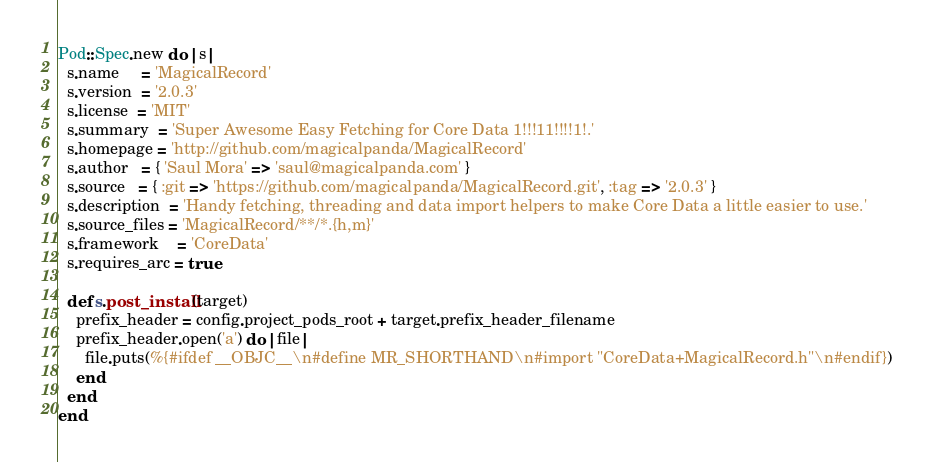Convert code to text. <code><loc_0><loc_0><loc_500><loc_500><_Ruby_>Pod::Spec.new do |s|
  s.name     = 'MagicalRecord'
  s.version  = '2.0.3'
  s.license  = 'MIT'
  s.summary  = 'Super Awesome Easy Fetching for Core Data 1!!!11!!!!1!.'
  s.homepage = 'http://github.com/magicalpanda/MagicalRecord'
  s.author   = { 'Saul Mora' => 'saul@magicalpanda.com' }
  s.source   = { :git => 'https://github.com/magicalpanda/MagicalRecord.git', :tag => '2.0.3' }
  s.description  = 'Handy fetching, threading and data import helpers to make Core Data a little easier to use.'
  s.source_files = 'MagicalRecord/**/*.{h,m}'
  s.framework    = 'CoreData'
  s.requires_arc = true

  def s.post_install(target)
    prefix_header = config.project_pods_root + target.prefix_header_filename
    prefix_header.open('a') do |file|
      file.puts(%{#ifdef __OBJC__\n#define MR_SHORTHAND\n#import "CoreData+MagicalRecord.h"\n#endif})
    end
  end
end
</code> 